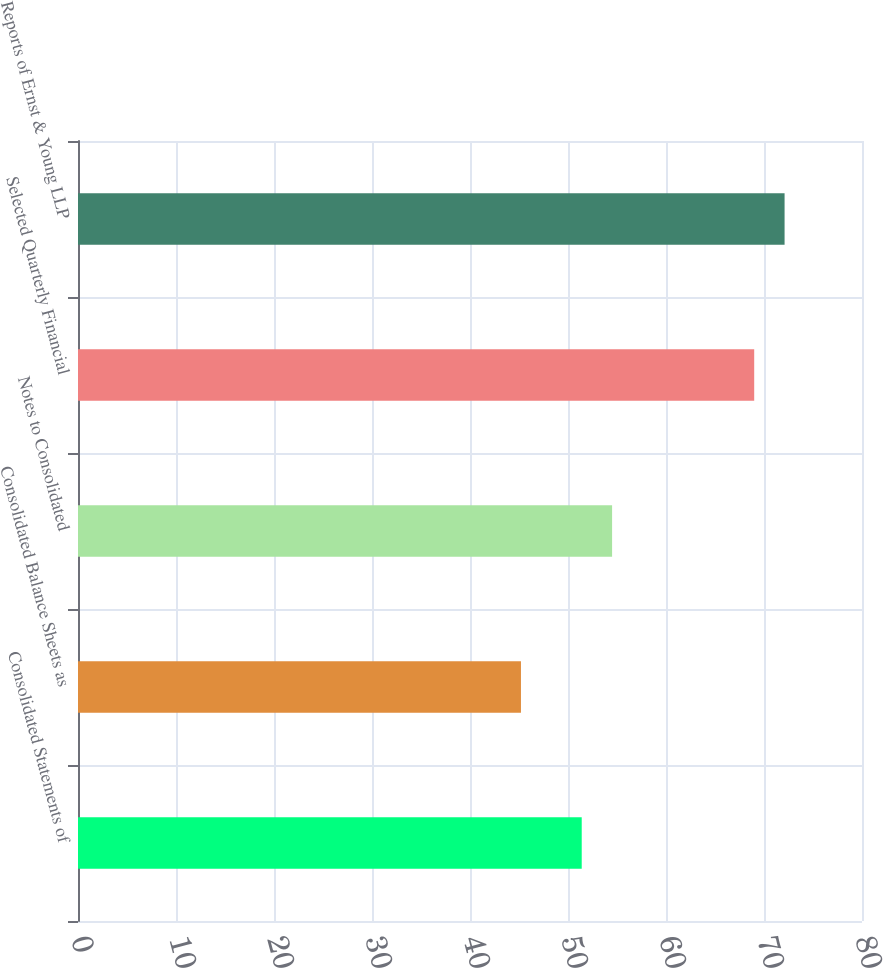<chart> <loc_0><loc_0><loc_500><loc_500><bar_chart><fcel>Consolidated Statements of<fcel>Consolidated Balance Sheets as<fcel>Notes to Consolidated<fcel>Selected Quarterly Financial<fcel>Reports of Ernst & Young LLP<nl><fcel>51.4<fcel>45.2<fcel>54.5<fcel>69<fcel>72.1<nl></chart> 